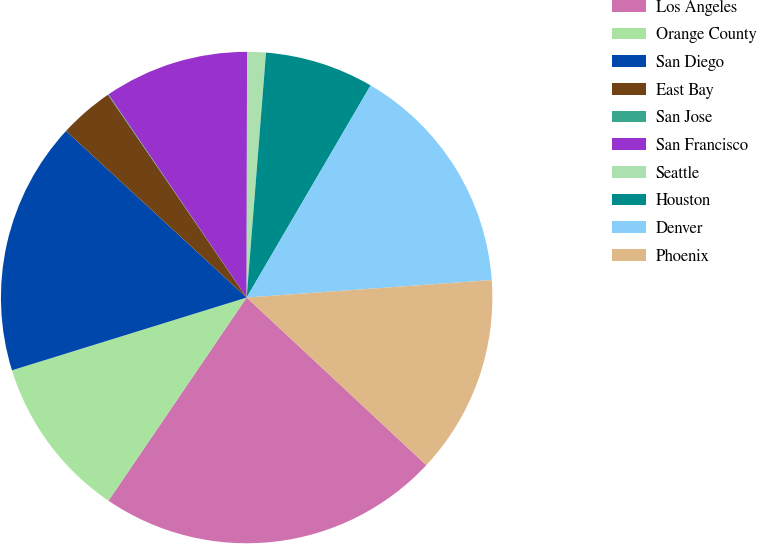Convert chart to OTSL. <chart><loc_0><loc_0><loc_500><loc_500><pie_chart><fcel>Los Angeles<fcel>Orange County<fcel>San Diego<fcel>East Bay<fcel>San Jose<fcel>San Francisco<fcel>Seattle<fcel>Houston<fcel>Denver<fcel>Phoenix<nl><fcel>22.56%<fcel>10.71%<fcel>16.64%<fcel>3.6%<fcel>0.04%<fcel>9.53%<fcel>1.23%<fcel>7.16%<fcel>15.45%<fcel>13.08%<nl></chart> 